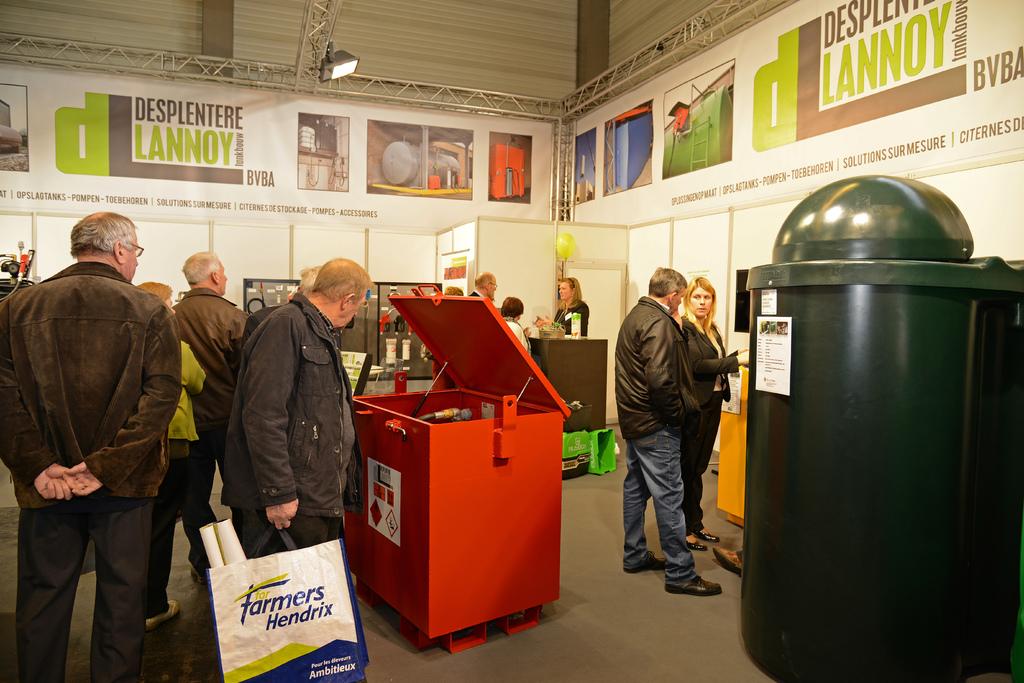What convention is this?
Your response must be concise. Unanswerable. What does the mans bag say?
Give a very brief answer. Farmers hendrix. 